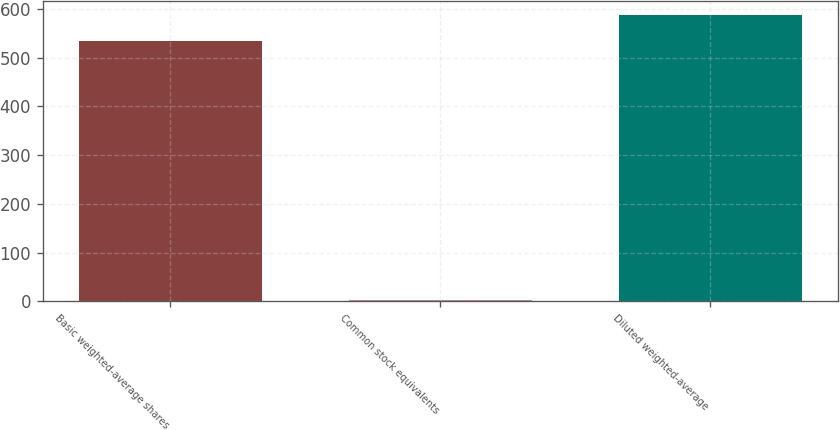Convert chart. <chart><loc_0><loc_0><loc_500><loc_500><bar_chart><fcel>Basic weighted-average shares<fcel>Common stock equivalents<fcel>Diluted weighted-average<nl><fcel>533.4<fcel>3.4<fcel>586.74<nl></chart> 